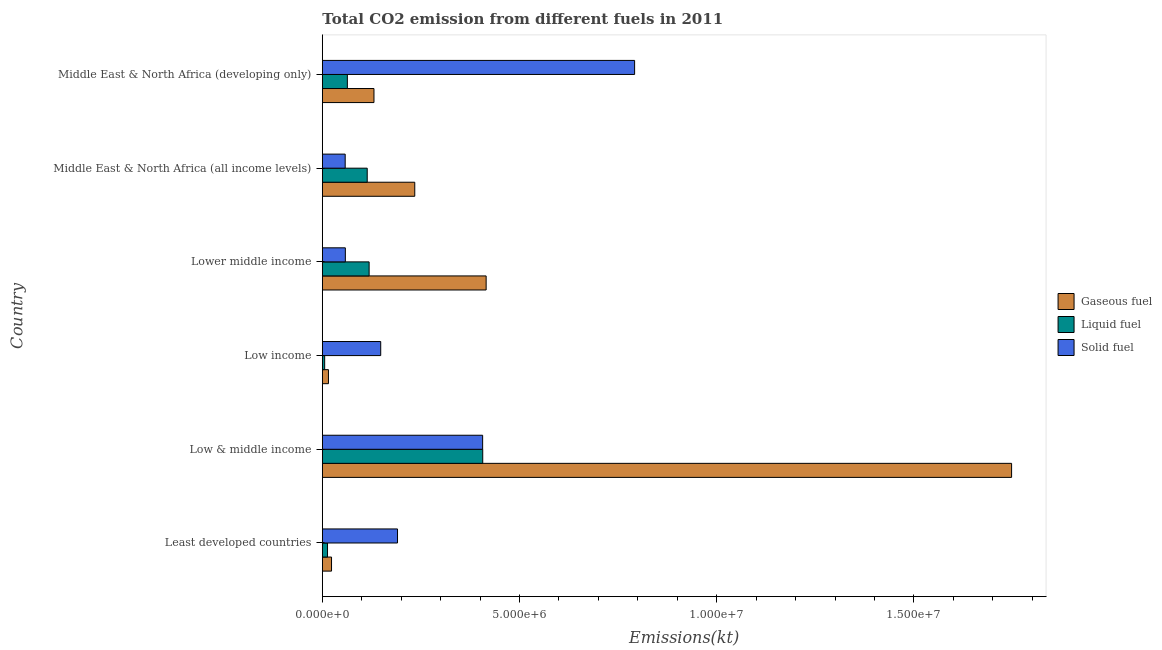How many different coloured bars are there?
Provide a short and direct response. 3. How many bars are there on the 4th tick from the top?
Ensure brevity in your answer.  3. How many bars are there on the 6th tick from the bottom?
Provide a short and direct response. 3. What is the label of the 6th group of bars from the top?
Keep it short and to the point. Least developed countries. In how many cases, is the number of bars for a given country not equal to the number of legend labels?
Your response must be concise. 0. What is the amount of co2 emissions from solid fuel in Middle East & North Africa (developing only)?
Ensure brevity in your answer.  7.92e+06. Across all countries, what is the maximum amount of co2 emissions from liquid fuel?
Provide a succinct answer. 4.07e+06. Across all countries, what is the minimum amount of co2 emissions from liquid fuel?
Your answer should be very brief. 5.92e+04. In which country was the amount of co2 emissions from solid fuel maximum?
Your answer should be compact. Middle East & North Africa (developing only). In which country was the amount of co2 emissions from liquid fuel minimum?
Provide a short and direct response. Low income. What is the total amount of co2 emissions from liquid fuel in the graph?
Give a very brief answer. 7.22e+06. What is the difference between the amount of co2 emissions from gaseous fuel in Least developed countries and that in Lower middle income?
Offer a terse response. -3.92e+06. What is the difference between the amount of co2 emissions from gaseous fuel in Low & middle income and the amount of co2 emissions from liquid fuel in Low income?
Keep it short and to the point. 1.74e+07. What is the average amount of co2 emissions from gaseous fuel per country?
Give a very brief answer. 4.28e+06. What is the difference between the amount of co2 emissions from gaseous fuel and amount of co2 emissions from solid fuel in Middle East & North Africa (all income levels)?
Provide a succinct answer. 1.76e+06. In how many countries, is the amount of co2 emissions from liquid fuel greater than 13000000 kt?
Give a very brief answer. 0. What is the ratio of the amount of co2 emissions from solid fuel in Lower middle income to that in Middle East & North Africa (all income levels)?
Provide a short and direct response. 1.01. What is the difference between the highest and the second highest amount of co2 emissions from gaseous fuel?
Provide a succinct answer. 1.33e+07. What is the difference between the highest and the lowest amount of co2 emissions from solid fuel?
Offer a terse response. 7.34e+06. In how many countries, is the amount of co2 emissions from solid fuel greater than the average amount of co2 emissions from solid fuel taken over all countries?
Keep it short and to the point. 2. What does the 1st bar from the top in Lower middle income represents?
Keep it short and to the point. Solid fuel. What does the 2nd bar from the bottom in Middle East & North Africa (developing only) represents?
Provide a short and direct response. Liquid fuel. Are all the bars in the graph horizontal?
Provide a succinct answer. Yes. How many countries are there in the graph?
Make the answer very short. 6. Are the values on the major ticks of X-axis written in scientific E-notation?
Provide a succinct answer. Yes. Does the graph contain any zero values?
Keep it short and to the point. No. How many legend labels are there?
Provide a short and direct response. 3. How are the legend labels stacked?
Your answer should be very brief. Vertical. What is the title of the graph?
Offer a very short reply. Total CO2 emission from different fuels in 2011. Does "Oil" appear as one of the legend labels in the graph?
Provide a short and direct response. No. What is the label or title of the X-axis?
Provide a succinct answer. Emissions(kt). What is the Emissions(kt) of Gaseous fuel in Least developed countries?
Your answer should be very brief. 2.33e+05. What is the Emissions(kt) in Liquid fuel in Least developed countries?
Your answer should be very brief. 1.31e+05. What is the Emissions(kt) of Solid fuel in Least developed countries?
Your answer should be compact. 1.91e+06. What is the Emissions(kt) of Gaseous fuel in Low & middle income?
Offer a very short reply. 1.75e+07. What is the Emissions(kt) in Liquid fuel in Low & middle income?
Offer a very short reply. 4.07e+06. What is the Emissions(kt) of Solid fuel in Low & middle income?
Your answer should be very brief. 4.06e+06. What is the Emissions(kt) of Gaseous fuel in Low income?
Provide a succinct answer. 1.55e+05. What is the Emissions(kt) in Liquid fuel in Low income?
Ensure brevity in your answer.  5.92e+04. What is the Emissions(kt) in Solid fuel in Low income?
Provide a short and direct response. 1.48e+06. What is the Emissions(kt) in Gaseous fuel in Lower middle income?
Keep it short and to the point. 4.15e+06. What is the Emissions(kt) of Liquid fuel in Lower middle income?
Give a very brief answer. 1.19e+06. What is the Emissions(kt) of Solid fuel in Lower middle income?
Make the answer very short. 5.83e+05. What is the Emissions(kt) in Gaseous fuel in Middle East & North Africa (all income levels)?
Your response must be concise. 2.34e+06. What is the Emissions(kt) in Liquid fuel in Middle East & North Africa (all income levels)?
Keep it short and to the point. 1.14e+06. What is the Emissions(kt) in Solid fuel in Middle East & North Africa (all income levels)?
Provide a short and direct response. 5.79e+05. What is the Emissions(kt) of Gaseous fuel in Middle East & North Africa (developing only)?
Your answer should be very brief. 1.31e+06. What is the Emissions(kt) of Liquid fuel in Middle East & North Africa (developing only)?
Your answer should be very brief. 6.35e+05. What is the Emissions(kt) of Solid fuel in Middle East & North Africa (developing only)?
Make the answer very short. 7.92e+06. Across all countries, what is the maximum Emissions(kt) of Gaseous fuel?
Provide a succinct answer. 1.75e+07. Across all countries, what is the maximum Emissions(kt) of Liquid fuel?
Ensure brevity in your answer.  4.07e+06. Across all countries, what is the maximum Emissions(kt) of Solid fuel?
Give a very brief answer. 7.92e+06. Across all countries, what is the minimum Emissions(kt) of Gaseous fuel?
Provide a short and direct response. 1.55e+05. Across all countries, what is the minimum Emissions(kt) in Liquid fuel?
Your answer should be compact. 5.92e+04. Across all countries, what is the minimum Emissions(kt) in Solid fuel?
Your answer should be very brief. 5.79e+05. What is the total Emissions(kt) in Gaseous fuel in the graph?
Offer a terse response. 2.57e+07. What is the total Emissions(kt) in Liquid fuel in the graph?
Ensure brevity in your answer.  7.22e+06. What is the total Emissions(kt) of Solid fuel in the graph?
Provide a succinct answer. 1.65e+07. What is the difference between the Emissions(kt) of Gaseous fuel in Least developed countries and that in Low & middle income?
Make the answer very short. -1.72e+07. What is the difference between the Emissions(kt) of Liquid fuel in Least developed countries and that in Low & middle income?
Keep it short and to the point. -3.94e+06. What is the difference between the Emissions(kt) in Solid fuel in Least developed countries and that in Low & middle income?
Provide a succinct answer. -2.16e+06. What is the difference between the Emissions(kt) of Gaseous fuel in Least developed countries and that in Low income?
Provide a short and direct response. 7.77e+04. What is the difference between the Emissions(kt) in Liquid fuel in Least developed countries and that in Low income?
Ensure brevity in your answer.  7.22e+04. What is the difference between the Emissions(kt) of Solid fuel in Least developed countries and that in Low income?
Keep it short and to the point. 4.26e+05. What is the difference between the Emissions(kt) in Gaseous fuel in Least developed countries and that in Lower middle income?
Your answer should be compact. -3.92e+06. What is the difference between the Emissions(kt) in Liquid fuel in Least developed countries and that in Lower middle income?
Give a very brief answer. -1.06e+06. What is the difference between the Emissions(kt) in Solid fuel in Least developed countries and that in Lower middle income?
Ensure brevity in your answer.  1.32e+06. What is the difference between the Emissions(kt) of Gaseous fuel in Least developed countries and that in Middle East & North Africa (all income levels)?
Give a very brief answer. -2.11e+06. What is the difference between the Emissions(kt) of Liquid fuel in Least developed countries and that in Middle East & North Africa (all income levels)?
Offer a very short reply. -1.01e+06. What is the difference between the Emissions(kt) in Solid fuel in Least developed countries and that in Middle East & North Africa (all income levels)?
Your answer should be compact. 1.33e+06. What is the difference between the Emissions(kt) in Gaseous fuel in Least developed countries and that in Middle East & North Africa (developing only)?
Ensure brevity in your answer.  -1.08e+06. What is the difference between the Emissions(kt) in Liquid fuel in Least developed countries and that in Middle East & North Africa (developing only)?
Offer a terse response. -5.03e+05. What is the difference between the Emissions(kt) of Solid fuel in Least developed countries and that in Middle East & North Africa (developing only)?
Offer a terse response. -6.01e+06. What is the difference between the Emissions(kt) of Gaseous fuel in Low & middle income and that in Low income?
Your answer should be very brief. 1.73e+07. What is the difference between the Emissions(kt) in Liquid fuel in Low & middle income and that in Low income?
Ensure brevity in your answer.  4.01e+06. What is the difference between the Emissions(kt) in Solid fuel in Low & middle income and that in Low income?
Make the answer very short. 2.58e+06. What is the difference between the Emissions(kt) of Gaseous fuel in Low & middle income and that in Lower middle income?
Ensure brevity in your answer.  1.33e+07. What is the difference between the Emissions(kt) of Liquid fuel in Low & middle income and that in Lower middle income?
Offer a terse response. 2.88e+06. What is the difference between the Emissions(kt) in Solid fuel in Low & middle income and that in Lower middle income?
Provide a succinct answer. 3.48e+06. What is the difference between the Emissions(kt) of Gaseous fuel in Low & middle income and that in Middle East & North Africa (all income levels)?
Offer a terse response. 1.51e+07. What is the difference between the Emissions(kt) in Liquid fuel in Low & middle income and that in Middle East & North Africa (all income levels)?
Keep it short and to the point. 2.93e+06. What is the difference between the Emissions(kt) in Solid fuel in Low & middle income and that in Middle East & North Africa (all income levels)?
Offer a terse response. 3.49e+06. What is the difference between the Emissions(kt) in Gaseous fuel in Low & middle income and that in Middle East & North Africa (developing only)?
Your answer should be very brief. 1.62e+07. What is the difference between the Emissions(kt) in Liquid fuel in Low & middle income and that in Middle East & North Africa (developing only)?
Make the answer very short. 3.43e+06. What is the difference between the Emissions(kt) of Solid fuel in Low & middle income and that in Middle East & North Africa (developing only)?
Make the answer very short. -3.85e+06. What is the difference between the Emissions(kt) of Gaseous fuel in Low income and that in Lower middle income?
Provide a short and direct response. -4.00e+06. What is the difference between the Emissions(kt) of Liquid fuel in Low income and that in Lower middle income?
Provide a short and direct response. -1.13e+06. What is the difference between the Emissions(kt) in Solid fuel in Low income and that in Lower middle income?
Your answer should be compact. 8.97e+05. What is the difference between the Emissions(kt) of Gaseous fuel in Low income and that in Middle East & North Africa (all income levels)?
Offer a terse response. -2.19e+06. What is the difference between the Emissions(kt) in Liquid fuel in Low income and that in Middle East & North Africa (all income levels)?
Make the answer very short. -1.08e+06. What is the difference between the Emissions(kt) of Solid fuel in Low income and that in Middle East & North Africa (all income levels)?
Keep it short and to the point. 9.01e+05. What is the difference between the Emissions(kt) of Gaseous fuel in Low income and that in Middle East & North Africa (developing only)?
Provide a short and direct response. -1.15e+06. What is the difference between the Emissions(kt) of Liquid fuel in Low income and that in Middle East & North Africa (developing only)?
Your response must be concise. -5.75e+05. What is the difference between the Emissions(kt) of Solid fuel in Low income and that in Middle East & North Africa (developing only)?
Your answer should be very brief. -6.44e+06. What is the difference between the Emissions(kt) of Gaseous fuel in Lower middle income and that in Middle East & North Africa (all income levels)?
Provide a succinct answer. 1.81e+06. What is the difference between the Emissions(kt) in Liquid fuel in Lower middle income and that in Middle East & North Africa (all income levels)?
Your answer should be compact. 4.86e+04. What is the difference between the Emissions(kt) of Solid fuel in Lower middle income and that in Middle East & North Africa (all income levels)?
Make the answer very short. 4057.85. What is the difference between the Emissions(kt) in Gaseous fuel in Lower middle income and that in Middle East & North Africa (developing only)?
Offer a terse response. 2.84e+06. What is the difference between the Emissions(kt) of Liquid fuel in Lower middle income and that in Middle East & North Africa (developing only)?
Your response must be concise. 5.52e+05. What is the difference between the Emissions(kt) in Solid fuel in Lower middle income and that in Middle East & North Africa (developing only)?
Make the answer very short. -7.33e+06. What is the difference between the Emissions(kt) in Gaseous fuel in Middle East & North Africa (all income levels) and that in Middle East & North Africa (developing only)?
Your answer should be compact. 1.03e+06. What is the difference between the Emissions(kt) in Liquid fuel in Middle East & North Africa (all income levels) and that in Middle East & North Africa (developing only)?
Your answer should be compact. 5.03e+05. What is the difference between the Emissions(kt) in Solid fuel in Middle East & North Africa (all income levels) and that in Middle East & North Africa (developing only)?
Make the answer very short. -7.34e+06. What is the difference between the Emissions(kt) in Gaseous fuel in Least developed countries and the Emissions(kt) in Liquid fuel in Low & middle income?
Give a very brief answer. -3.83e+06. What is the difference between the Emissions(kt) in Gaseous fuel in Least developed countries and the Emissions(kt) in Solid fuel in Low & middle income?
Ensure brevity in your answer.  -3.83e+06. What is the difference between the Emissions(kt) in Liquid fuel in Least developed countries and the Emissions(kt) in Solid fuel in Low & middle income?
Ensure brevity in your answer.  -3.93e+06. What is the difference between the Emissions(kt) in Gaseous fuel in Least developed countries and the Emissions(kt) in Liquid fuel in Low income?
Your response must be concise. 1.74e+05. What is the difference between the Emissions(kt) in Gaseous fuel in Least developed countries and the Emissions(kt) in Solid fuel in Low income?
Provide a succinct answer. -1.25e+06. What is the difference between the Emissions(kt) of Liquid fuel in Least developed countries and the Emissions(kt) of Solid fuel in Low income?
Give a very brief answer. -1.35e+06. What is the difference between the Emissions(kt) in Gaseous fuel in Least developed countries and the Emissions(kt) in Liquid fuel in Lower middle income?
Offer a terse response. -9.53e+05. What is the difference between the Emissions(kt) of Gaseous fuel in Least developed countries and the Emissions(kt) of Solid fuel in Lower middle income?
Offer a terse response. -3.50e+05. What is the difference between the Emissions(kt) in Liquid fuel in Least developed countries and the Emissions(kt) in Solid fuel in Lower middle income?
Your answer should be compact. -4.52e+05. What is the difference between the Emissions(kt) in Gaseous fuel in Least developed countries and the Emissions(kt) in Liquid fuel in Middle East & North Africa (all income levels)?
Your response must be concise. -9.05e+05. What is the difference between the Emissions(kt) of Gaseous fuel in Least developed countries and the Emissions(kt) of Solid fuel in Middle East & North Africa (all income levels)?
Your answer should be very brief. -3.46e+05. What is the difference between the Emissions(kt) in Liquid fuel in Least developed countries and the Emissions(kt) in Solid fuel in Middle East & North Africa (all income levels)?
Your answer should be very brief. -4.48e+05. What is the difference between the Emissions(kt) in Gaseous fuel in Least developed countries and the Emissions(kt) in Liquid fuel in Middle East & North Africa (developing only)?
Offer a terse response. -4.01e+05. What is the difference between the Emissions(kt) in Gaseous fuel in Least developed countries and the Emissions(kt) in Solid fuel in Middle East & North Africa (developing only)?
Provide a short and direct response. -7.68e+06. What is the difference between the Emissions(kt) in Liquid fuel in Least developed countries and the Emissions(kt) in Solid fuel in Middle East & North Africa (developing only)?
Offer a very short reply. -7.79e+06. What is the difference between the Emissions(kt) of Gaseous fuel in Low & middle income and the Emissions(kt) of Liquid fuel in Low income?
Offer a terse response. 1.74e+07. What is the difference between the Emissions(kt) of Gaseous fuel in Low & middle income and the Emissions(kt) of Solid fuel in Low income?
Offer a terse response. 1.60e+07. What is the difference between the Emissions(kt) of Liquid fuel in Low & middle income and the Emissions(kt) of Solid fuel in Low income?
Provide a short and direct response. 2.59e+06. What is the difference between the Emissions(kt) of Gaseous fuel in Low & middle income and the Emissions(kt) of Liquid fuel in Lower middle income?
Offer a very short reply. 1.63e+07. What is the difference between the Emissions(kt) in Gaseous fuel in Low & middle income and the Emissions(kt) in Solid fuel in Lower middle income?
Your answer should be very brief. 1.69e+07. What is the difference between the Emissions(kt) in Liquid fuel in Low & middle income and the Emissions(kt) in Solid fuel in Lower middle income?
Ensure brevity in your answer.  3.48e+06. What is the difference between the Emissions(kt) in Gaseous fuel in Low & middle income and the Emissions(kt) in Liquid fuel in Middle East & North Africa (all income levels)?
Give a very brief answer. 1.63e+07. What is the difference between the Emissions(kt) in Gaseous fuel in Low & middle income and the Emissions(kt) in Solid fuel in Middle East & North Africa (all income levels)?
Keep it short and to the point. 1.69e+07. What is the difference between the Emissions(kt) of Liquid fuel in Low & middle income and the Emissions(kt) of Solid fuel in Middle East & North Africa (all income levels)?
Ensure brevity in your answer.  3.49e+06. What is the difference between the Emissions(kt) in Gaseous fuel in Low & middle income and the Emissions(kt) in Liquid fuel in Middle East & North Africa (developing only)?
Offer a very short reply. 1.68e+07. What is the difference between the Emissions(kt) in Gaseous fuel in Low & middle income and the Emissions(kt) in Solid fuel in Middle East & North Africa (developing only)?
Offer a terse response. 9.56e+06. What is the difference between the Emissions(kt) in Liquid fuel in Low & middle income and the Emissions(kt) in Solid fuel in Middle East & North Africa (developing only)?
Provide a short and direct response. -3.85e+06. What is the difference between the Emissions(kt) in Gaseous fuel in Low income and the Emissions(kt) in Liquid fuel in Lower middle income?
Your answer should be very brief. -1.03e+06. What is the difference between the Emissions(kt) in Gaseous fuel in Low income and the Emissions(kt) in Solid fuel in Lower middle income?
Make the answer very short. -4.28e+05. What is the difference between the Emissions(kt) in Liquid fuel in Low income and the Emissions(kt) in Solid fuel in Lower middle income?
Give a very brief answer. -5.24e+05. What is the difference between the Emissions(kt) of Gaseous fuel in Low income and the Emissions(kt) of Liquid fuel in Middle East & North Africa (all income levels)?
Provide a short and direct response. -9.83e+05. What is the difference between the Emissions(kt) in Gaseous fuel in Low income and the Emissions(kt) in Solid fuel in Middle East & North Africa (all income levels)?
Your response must be concise. -4.24e+05. What is the difference between the Emissions(kt) in Liquid fuel in Low income and the Emissions(kt) in Solid fuel in Middle East & North Africa (all income levels)?
Keep it short and to the point. -5.20e+05. What is the difference between the Emissions(kt) in Gaseous fuel in Low income and the Emissions(kt) in Liquid fuel in Middle East & North Africa (developing only)?
Your answer should be compact. -4.79e+05. What is the difference between the Emissions(kt) of Gaseous fuel in Low income and the Emissions(kt) of Solid fuel in Middle East & North Africa (developing only)?
Offer a very short reply. -7.76e+06. What is the difference between the Emissions(kt) in Liquid fuel in Low income and the Emissions(kt) in Solid fuel in Middle East & North Africa (developing only)?
Provide a short and direct response. -7.86e+06. What is the difference between the Emissions(kt) in Gaseous fuel in Lower middle income and the Emissions(kt) in Liquid fuel in Middle East & North Africa (all income levels)?
Make the answer very short. 3.01e+06. What is the difference between the Emissions(kt) of Gaseous fuel in Lower middle income and the Emissions(kt) of Solid fuel in Middle East & North Africa (all income levels)?
Your answer should be very brief. 3.57e+06. What is the difference between the Emissions(kt) in Liquid fuel in Lower middle income and the Emissions(kt) in Solid fuel in Middle East & North Africa (all income levels)?
Provide a short and direct response. 6.07e+05. What is the difference between the Emissions(kt) of Gaseous fuel in Lower middle income and the Emissions(kt) of Liquid fuel in Middle East & North Africa (developing only)?
Ensure brevity in your answer.  3.52e+06. What is the difference between the Emissions(kt) of Gaseous fuel in Lower middle income and the Emissions(kt) of Solid fuel in Middle East & North Africa (developing only)?
Your answer should be compact. -3.76e+06. What is the difference between the Emissions(kt) of Liquid fuel in Lower middle income and the Emissions(kt) of Solid fuel in Middle East & North Africa (developing only)?
Provide a succinct answer. -6.73e+06. What is the difference between the Emissions(kt) in Gaseous fuel in Middle East & North Africa (all income levels) and the Emissions(kt) in Liquid fuel in Middle East & North Africa (developing only)?
Give a very brief answer. 1.71e+06. What is the difference between the Emissions(kt) of Gaseous fuel in Middle East & North Africa (all income levels) and the Emissions(kt) of Solid fuel in Middle East & North Africa (developing only)?
Provide a succinct answer. -5.57e+06. What is the difference between the Emissions(kt) of Liquid fuel in Middle East & North Africa (all income levels) and the Emissions(kt) of Solid fuel in Middle East & North Africa (developing only)?
Provide a short and direct response. -6.78e+06. What is the average Emissions(kt) in Gaseous fuel per country?
Make the answer very short. 4.28e+06. What is the average Emissions(kt) of Liquid fuel per country?
Make the answer very short. 1.20e+06. What is the average Emissions(kt) of Solid fuel per country?
Your response must be concise. 2.76e+06. What is the difference between the Emissions(kt) in Gaseous fuel and Emissions(kt) in Liquid fuel in Least developed countries?
Provide a short and direct response. 1.02e+05. What is the difference between the Emissions(kt) in Gaseous fuel and Emissions(kt) in Solid fuel in Least developed countries?
Your response must be concise. -1.67e+06. What is the difference between the Emissions(kt) in Liquid fuel and Emissions(kt) in Solid fuel in Least developed countries?
Your answer should be very brief. -1.77e+06. What is the difference between the Emissions(kt) in Gaseous fuel and Emissions(kt) in Liquid fuel in Low & middle income?
Give a very brief answer. 1.34e+07. What is the difference between the Emissions(kt) of Gaseous fuel and Emissions(kt) of Solid fuel in Low & middle income?
Give a very brief answer. 1.34e+07. What is the difference between the Emissions(kt) of Liquid fuel and Emissions(kt) of Solid fuel in Low & middle income?
Offer a terse response. 2523.07. What is the difference between the Emissions(kt) of Gaseous fuel and Emissions(kt) of Liquid fuel in Low income?
Provide a succinct answer. 9.62e+04. What is the difference between the Emissions(kt) in Gaseous fuel and Emissions(kt) in Solid fuel in Low income?
Your answer should be very brief. -1.33e+06. What is the difference between the Emissions(kt) of Liquid fuel and Emissions(kt) of Solid fuel in Low income?
Offer a very short reply. -1.42e+06. What is the difference between the Emissions(kt) of Gaseous fuel and Emissions(kt) of Liquid fuel in Lower middle income?
Make the answer very short. 2.97e+06. What is the difference between the Emissions(kt) in Gaseous fuel and Emissions(kt) in Solid fuel in Lower middle income?
Make the answer very short. 3.57e+06. What is the difference between the Emissions(kt) of Liquid fuel and Emissions(kt) of Solid fuel in Lower middle income?
Make the answer very short. 6.03e+05. What is the difference between the Emissions(kt) of Gaseous fuel and Emissions(kt) of Liquid fuel in Middle East & North Africa (all income levels)?
Ensure brevity in your answer.  1.21e+06. What is the difference between the Emissions(kt) of Gaseous fuel and Emissions(kt) of Solid fuel in Middle East & North Africa (all income levels)?
Ensure brevity in your answer.  1.76e+06. What is the difference between the Emissions(kt) of Liquid fuel and Emissions(kt) of Solid fuel in Middle East & North Africa (all income levels)?
Offer a very short reply. 5.59e+05. What is the difference between the Emissions(kt) of Gaseous fuel and Emissions(kt) of Liquid fuel in Middle East & North Africa (developing only)?
Keep it short and to the point. 6.75e+05. What is the difference between the Emissions(kt) of Gaseous fuel and Emissions(kt) of Solid fuel in Middle East & North Africa (developing only)?
Your answer should be very brief. -6.61e+06. What is the difference between the Emissions(kt) of Liquid fuel and Emissions(kt) of Solid fuel in Middle East & North Africa (developing only)?
Keep it short and to the point. -7.28e+06. What is the ratio of the Emissions(kt) of Gaseous fuel in Least developed countries to that in Low & middle income?
Ensure brevity in your answer.  0.01. What is the ratio of the Emissions(kt) in Liquid fuel in Least developed countries to that in Low & middle income?
Ensure brevity in your answer.  0.03. What is the ratio of the Emissions(kt) of Solid fuel in Least developed countries to that in Low & middle income?
Your answer should be compact. 0.47. What is the ratio of the Emissions(kt) in Liquid fuel in Least developed countries to that in Low income?
Your answer should be compact. 2.22. What is the ratio of the Emissions(kt) in Solid fuel in Least developed countries to that in Low income?
Your answer should be compact. 1.29. What is the ratio of the Emissions(kt) of Gaseous fuel in Least developed countries to that in Lower middle income?
Your answer should be compact. 0.06. What is the ratio of the Emissions(kt) of Liquid fuel in Least developed countries to that in Lower middle income?
Offer a very short reply. 0.11. What is the ratio of the Emissions(kt) of Solid fuel in Least developed countries to that in Lower middle income?
Ensure brevity in your answer.  3.27. What is the ratio of the Emissions(kt) of Gaseous fuel in Least developed countries to that in Middle East & North Africa (all income levels)?
Ensure brevity in your answer.  0.1. What is the ratio of the Emissions(kt) of Liquid fuel in Least developed countries to that in Middle East & North Africa (all income levels)?
Keep it short and to the point. 0.12. What is the ratio of the Emissions(kt) of Solid fuel in Least developed countries to that in Middle East & North Africa (all income levels)?
Make the answer very short. 3.29. What is the ratio of the Emissions(kt) in Gaseous fuel in Least developed countries to that in Middle East & North Africa (developing only)?
Provide a succinct answer. 0.18. What is the ratio of the Emissions(kt) in Liquid fuel in Least developed countries to that in Middle East & North Africa (developing only)?
Offer a terse response. 0.21. What is the ratio of the Emissions(kt) of Solid fuel in Least developed countries to that in Middle East & North Africa (developing only)?
Your answer should be compact. 0.24. What is the ratio of the Emissions(kt) in Gaseous fuel in Low & middle income to that in Low income?
Your answer should be compact. 112.43. What is the ratio of the Emissions(kt) in Liquid fuel in Low & middle income to that in Low income?
Your answer should be compact. 68.65. What is the ratio of the Emissions(kt) in Solid fuel in Low & middle income to that in Low income?
Your answer should be compact. 2.75. What is the ratio of the Emissions(kt) of Gaseous fuel in Low & middle income to that in Lower middle income?
Provide a succinct answer. 4.21. What is the ratio of the Emissions(kt) in Liquid fuel in Low & middle income to that in Lower middle income?
Your answer should be compact. 3.43. What is the ratio of the Emissions(kt) in Solid fuel in Low & middle income to that in Lower middle income?
Ensure brevity in your answer.  6.97. What is the ratio of the Emissions(kt) in Gaseous fuel in Low & middle income to that in Middle East & North Africa (all income levels)?
Ensure brevity in your answer.  7.46. What is the ratio of the Emissions(kt) in Liquid fuel in Low & middle income to that in Middle East & North Africa (all income levels)?
Your answer should be very brief. 3.57. What is the ratio of the Emissions(kt) of Solid fuel in Low & middle income to that in Middle East & North Africa (all income levels)?
Provide a short and direct response. 7.02. What is the ratio of the Emissions(kt) of Gaseous fuel in Low & middle income to that in Middle East & North Africa (developing only)?
Provide a short and direct response. 13.35. What is the ratio of the Emissions(kt) of Liquid fuel in Low & middle income to that in Middle East & North Africa (developing only)?
Give a very brief answer. 6.41. What is the ratio of the Emissions(kt) of Solid fuel in Low & middle income to that in Middle East & North Africa (developing only)?
Your answer should be compact. 0.51. What is the ratio of the Emissions(kt) in Gaseous fuel in Low income to that in Lower middle income?
Your answer should be very brief. 0.04. What is the ratio of the Emissions(kt) in Liquid fuel in Low income to that in Lower middle income?
Your answer should be compact. 0.05. What is the ratio of the Emissions(kt) of Solid fuel in Low income to that in Lower middle income?
Provide a short and direct response. 2.54. What is the ratio of the Emissions(kt) in Gaseous fuel in Low income to that in Middle East & North Africa (all income levels)?
Your response must be concise. 0.07. What is the ratio of the Emissions(kt) in Liquid fuel in Low income to that in Middle East & North Africa (all income levels)?
Provide a succinct answer. 0.05. What is the ratio of the Emissions(kt) in Solid fuel in Low income to that in Middle East & North Africa (all income levels)?
Your answer should be very brief. 2.56. What is the ratio of the Emissions(kt) of Gaseous fuel in Low income to that in Middle East & North Africa (developing only)?
Give a very brief answer. 0.12. What is the ratio of the Emissions(kt) of Liquid fuel in Low income to that in Middle East & North Africa (developing only)?
Give a very brief answer. 0.09. What is the ratio of the Emissions(kt) of Solid fuel in Low income to that in Middle East & North Africa (developing only)?
Give a very brief answer. 0.19. What is the ratio of the Emissions(kt) of Gaseous fuel in Lower middle income to that in Middle East & North Africa (all income levels)?
Provide a short and direct response. 1.77. What is the ratio of the Emissions(kt) in Liquid fuel in Lower middle income to that in Middle East & North Africa (all income levels)?
Your answer should be compact. 1.04. What is the ratio of the Emissions(kt) in Solid fuel in Lower middle income to that in Middle East & North Africa (all income levels)?
Offer a very short reply. 1.01. What is the ratio of the Emissions(kt) in Gaseous fuel in Lower middle income to that in Middle East & North Africa (developing only)?
Offer a very short reply. 3.17. What is the ratio of the Emissions(kt) in Liquid fuel in Lower middle income to that in Middle East & North Africa (developing only)?
Make the answer very short. 1.87. What is the ratio of the Emissions(kt) of Solid fuel in Lower middle income to that in Middle East & North Africa (developing only)?
Offer a terse response. 0.07. What is the ratio of the Emissions(kt) of Gaseous fuel in Middle East & North Africa (all income levels) to that in Middle East & North Africa (developing only)?
Keep it short and to the point. 1.79. What is the ratio of the Emissions(kt) of Liquid fuel in Middle East & North Africa (all income levels) to that in Middle East & North Africa (developing only)?
Your answer should be compact. 1.79. What is the ratio of the Emissions(kt) of Solid fuel in Middle East & North Africa (all income levels) to that in Middle East & North Africa (developing only)?
Offer a terse response. 0.07. What is the difference between the highest and the second highest Emissions(kt) in Gaseous fuel?
Your answer should be compact. 1.33e+07. What is the difference between the highest and the second highest Emissions(kt) in Liquid fuel?
Your answer should be very brief. 2.88e+06. What is the difference between the highest and the second highest Emissions(kt) of Solid fuel?
Your answer should be very brief. 3.85e+06. What is the difference between the highest and the lowest Emissions(kt) of Gaseous fuel?
Provide a short and direct response. 1.73e+07. What is the difference between the highest and the lowest Emissions(kt) in Liquid fuel?
Offer a terse response. 4.01e+06. What is the difference between the highest and the lowest Emissions(kt) of Solid fuel?
Offer a terse response. 7.34e+06. 